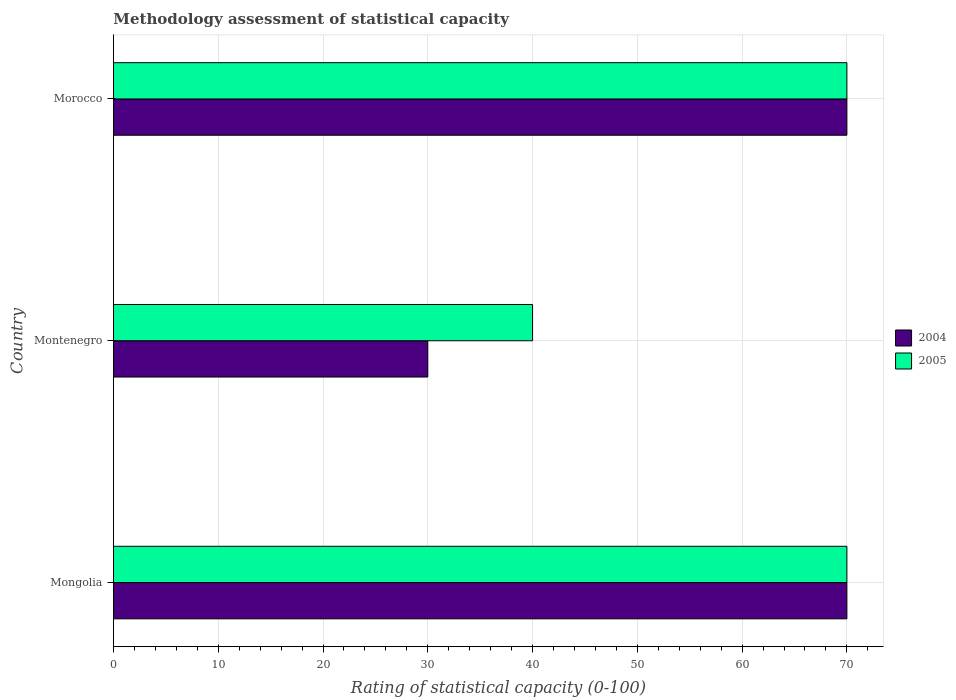How many different coloured bars are there?
Give a very brief answer. 2. How many groups of bars are there?
Provide a succinct answer. 3. How many bars are there on the 1st tick from the top?
Provide a short and direct response. 2. How many bars are there on the 1st tick from the bottom?
Your answer should be compact. 2. What is the label of the 3rd group of bars from the top?
Ensure brevity in your answer.  Mongolia. In how many cases, is the number of bars for a given country not equal to the number of legend labels?
Your response must be concise. 0. Across all countries, what is the minimum rating of statistical capacity in 2005?
Make the answer very short. 40. In which country was the rating of statistical capacity in 2005 maximum?
Keep it short and to the point. Mongolia. In which country was the rating of statistical capacity in 2004 minimum?
Make the answer very short. Montenegro. What is the total rating of statistical capacity in 2004 in the graph?
Provide a short and direct response. 170. What is the difference between the rating of statistical capacity in 2005 and rating of statistical capacity in 2004 in Mongolia?
Your answer should be compact. 0. In how many countries, is the rating of statistical capacity in 2004 greater than 26 ?
Make the answer very short. 3. What is the ratio of the rating of statistical capacity in 2004 in Mongolia to that in Montenegro?
Offer a terse response. 2.33. In how many countries, is the rating of statistical capacity in 2005 greater than the average rating of statistical capacity in 2005 taken over all countries?
Ensure brevity in your answer.  2. What does the 2nd bar from the top in Morocco represents?
Offer a terse response. 2004. What does the 1st bar from the bottom in Montenegro represents?
Your response must be concise. 2004. How many bars are there?
Your answer should be very brief. 6. Are the values on the major ticks of X-axis written in scientific E-notation?
Give a very brief answer. No. Does the graph contain grids?
Your response must be concise. Yes. Where does the legend appear in the graph?
Provide a short and direct response. Center right. How many legend labels are there?
Offer a terse response. 2. What is the title of the graph?
Make the answer very short. Methodology assessment of statistical capacity. What is the label or title of the X-axis?
Offer a very short reply. Rating of statistical capacity (0-100). What is the label or title of the Y-axis?
Your response must be concise. Country. What is the Rating of statistical capacity (0-100) in 2004 in Montenegro?
Make the answer very short. 30. What is the Rating of statistical capacity (0-100) in 2005 in Montenegro?
Ensure brevity in your answer.  40. Across all countries, what is the maximum Rating of statistical capacity (0-100) of 2005?
Offer a terse response. 70. What is the total Rating of statistical capacity (0-100) of 2004 in the graph?
Your answer should be very brief. 170. What is the total Rating of statistical capacity (0-100) in 2005 in the graph?
Your response must be concise. 180. What is the difference between the Rating of statistical capacity (0-100) of 2004 in Mongolia and that in Montenegro?
Your answer should be very brief. 40. What is the difference between the Rating of statistical capacity (0-100) in 2005 in Mongolia and that in Morocco?
Offer a terse response. 0. What is the difference between the Rating of statistical capacity (0-100) in 2005 in Montenegro and that in Morocco?
Provide a succinct answer. -30. What is the difference between the Rating of statistical capacity (0-100) in 2004 in Montenegro and the Rating of statistical capacity (0-100) in 2005 in Morocco?
Your answer should be compact. -40. What is the average Rating of statistical capacity (0-100) in 2004 per country?
Provide a short and direct response. 56.67. What is the difference between the Rating of statistical capacity (0-100) in 2004 and Rating of statistical capacity (0-100) in 2005 in Montenegro?
Offer a terse response. -10. What is the difference between the Rating of statistical capacity (0-100) in 2004 and Rating of statistical capacity (0-100) in 2005 in Morocco?
Your answer should be very brief. 0. What is the ratio of the Rating of statistical capacity (0-100) of 2004 in Mongolia to that in Montenegro?
Provide a short and direct response. 2.33. What is the ratio of the Rating of statistical capacity (0-100) of 2005 in Mongolia to that in Montenegro?
Ensure brevity in your answer.  1.75. What is the ratio of the Rating of statistical capacity (0-100) of 2005 in Mongolia to that in Morocco?
Provide a short and direct response. 1. What is the ratio of the Rating of statistical capacity (0-100) of 2004 in Montenegro to that in Morocco?
Offer a very short reply. 0.43. What is the difference between the highest and the lowest Rating of statistical capacity (0-100) of 2004?
Your answer should be compact. 40. What is the difference between the highest and the lowest Rating of statistical capacity (0-100) of 2005?
Provide a short and direct response. 30. 